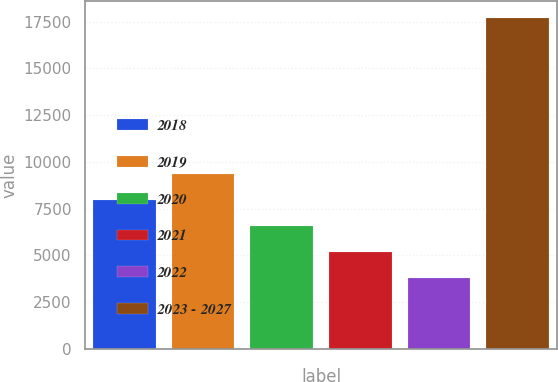Convert chart. <chart><loc_0><loc_0><loc_500><loc_500><bar_chart><fcel>2018<fcel>2019<fcel>2020<fcel>2021<fcel>2022<fcel>2023 - 2027<nl><fcel>7969.4<fcel>9359.2<fcel>6579.6<fcel>5189.8<fcel>3800<fcel>17698<nl></chart> 